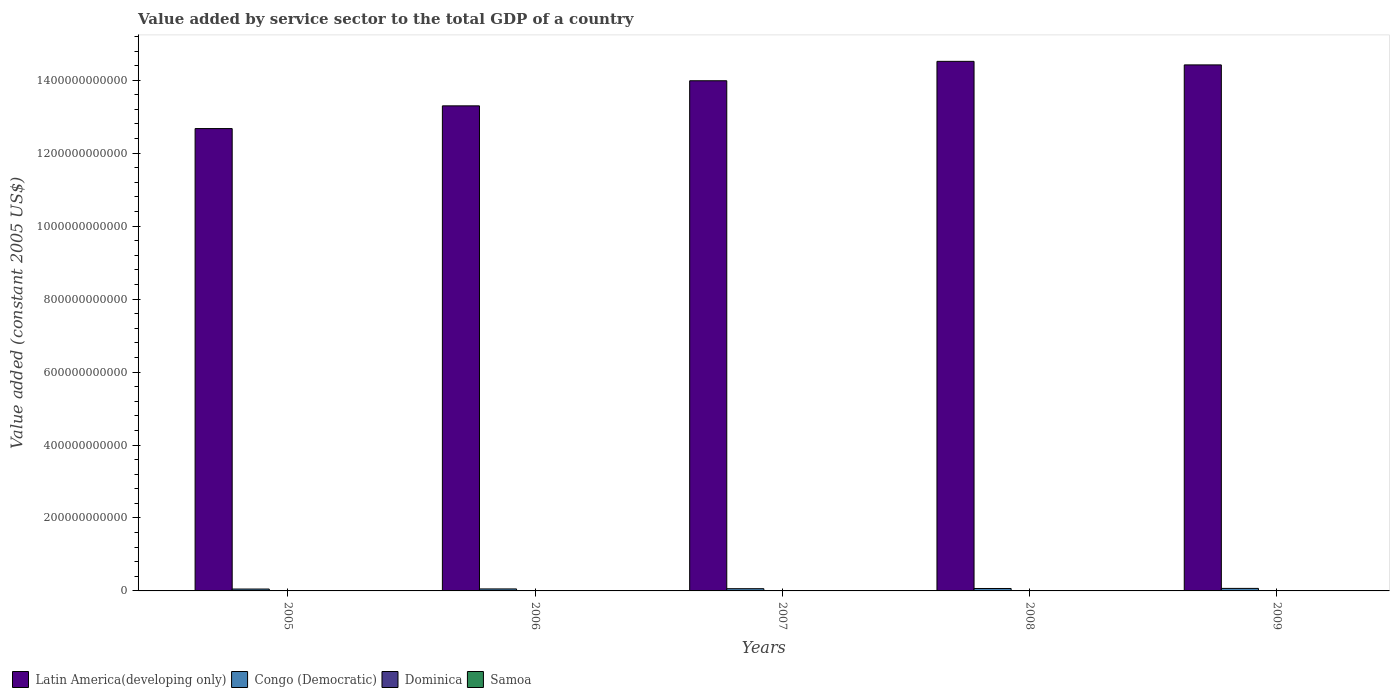How many groups of bars are there?
Make the answer very short. 5. Are the number of bars per tick equal to the number of legend labels?
Offer a terse response. Yes. Are the number of bars on each tick of the X-axis equal?
Provide a short and direct response. Yes. How many bars are there on the 5th tick from the right?
Offer a terse response. 4. What is the value added by service sector in Dominica in 2009?
Offer a very short reply. 2.55e+08. Across all years, what is the maximum value added by service sector in Dominica?
Your answer should be compact. 2.55e+08. Across all years, what is the minimum value added by service sector in Samoa?
Offer a terse response. 2.63e+08. What is the total value added by service sector in Congo (Democratic) in the graph?
Keep it short and to the point. 3.03e+1. What is the difference between the value added by service sector in Samoa in 2008 and that in 2009?
Ensure brevity in your answer.  -4.39e+06. What is the difference between the value added by service sector in Samoa in 2007 and the value added by service sector in Latin America(developing only) in 2006?
Your answer should be compact. -1.33e+12. What is the average value added by service sector in Dominica per year?
Your response must be concise. 2.40e+08. In the year 2008, what is the difference between the value added by service sector in Dominica and value added by service sector in Latin America(developing only)?
Provide a short and direct response. -1.45e+12. In how many years, is the value added by service sector in Dominica greater than 360000000000 US$?
Offer a very short reply. 0. What is the ratio of the value added by service sector in Latin America(developing only) in 2006 to that in 2009?
Make the answer very short. 0.92. Is the difference between the value added by service sector in Dominica in 2005 and 2008 greater than the difference between the value added by service sector in Latin America(developing only) in 2005 and 2008?
Offer a very short reply. Yes. What is the difference between the highest and the second highest value added by service sector in Dominica?
Your answer should be very brief. 1.10e+06. What is the difference between the highest and the lowest value added by service sector in Samoa?
Give a very brief answer. 3.37e+07. In how many years, is the value added by service sector in Congo (Democratic) greater than the average value added by service sector in Congo (Democratic) taken over all years?
Offer a very short reply. 3. What does the 2nd bar from the left in 2005 represents?
Your answer should be very brief. Congo (Democratic). What does the 3rd bar from the right in 2008 represents?
Provide a short and direct response. Congo (Democratic). Is it the case that in every year, the sum of the value added by service sector in Samoa and value added by service sector in Dominica is greater than the value added by service sector in Congo (Democratic)?
Your answer should be compact. No. How many bars are there?
Offer a terse response. 20. What is the difference between two consecutive major ticks on the Y-axis?
Ensure brevity in your answer.  2.00e+11. Does the graph contain any zero values?
Offer a very short reply. No. Does the graph contain grids?
Provide a succinct answer. No. Where does the legend appear in the graph?
Your answer should be very brief. Bottom left. How are the legend labels stacked?
Keep it short and to the point. Horizontal. What is the title of the graph?
Keep it short and to the point. Value added by service sector to the total GDP of a country. What is the label or title of the X-axis?
Ensure brevity in your answer.  Years. What is the label or title of the Y-axis?
Make the answer very short. Value added (constant 2005 US$). What is the Value added (constant 2005 US$) of Latin America(developing only) in 2005?
Your response must be concise. 1.27e+12. What is the Value added (constant 2005 US$) in Congo (Democratic) in 2005?
Offer a very short reply. 5.15e+09. What is the Value added (constant 2005 US$) in Dominica in 2005?
Your answer should be very brief. 2.25e+08. What is the Value added (constant 2005 US$) in Samoa in 2005?
Offer a very short reply. 2.63e+08. What is the Value added (constant 2005 US$) of Latin America(developing only) in 2006?
Keep it short and to the point. 1.33e+12. What is the Value added (constant 2005 US$) in Congo (Democratic) in 2006?
Give a very brief answer. 5.47e+09. What is the Value added (constant 2005 US$) of Dominica in 2006?
Keep it short and to the point. 2.27e+08. What is the Value added (constant 2005 US$) in Samoa in 2006?
Keep it short and to the point. 2.75e+08. What is the Value added (constant 2005 US$) in Latin America(developing only) in 2007?
Make the answer very short. 1.40e+12. What is the Value added (constant 2005 US$) in Congo (Democratic) in 2007?
Offer a terse response. 6.09e+09. What is the Value added (constant 2005 US$) of Dominica in 2007?
Provide a succinct answer. 2.40e+08. What is the Value added (constant 2005 US$) in Samoa in 2007?
Give a very brief answer. 2.84e+08. What is the Value added (constant 2005 US$) in Latin America(developing only) in 2008?
Offer a very short reply. 1.45e+12. What is the Value added (constant 2005 US$) in Congo (Democratic) in 2008?
Ensure brevity in your answer.  6.65e+09. What is the Value added (constant 2005 US$) of Dominica in 2008?
Give a very brief answer. 2.54e+08. What is the Value added (constant 2005 US$) in Samoa in 2008?
Provide a short and direct response. 2.93e+08. What is the Value added (constant 2005 US$) in Latin America(developing only) in 2009?
Provide a succinct answer. 1.44e+12. What is the Value added (constant 2005 US$) in Congo (Democratic) in 2009?
Your response must be concise. 6.90e+09. What is the Value added (constant 2005 US$) in Dominica in 2009?
Your answer should be very brief. 2.55e+08. What is the Value added (constant 2005 US$) in Samoa in 2009?
Your response must be concise. 2.97e+08. Across all years, what is the maximum Value added (constant 2005 US$) of Latin America(developing only)?
Provide a succinct answer. 1.45e+12. Across all years, what is the maximum Value added (constant 2005 US$) of Congo (Democratic)?
Make the answer very short. 6.90e+09. Across all years, what is the maximum Value added (constant 2005 US$) of Dominica?
Keep it short and to the point. 2.55e+08. Across all years, what is the maximum Value added (constant 2005 US$) of Samoa?
Make the answer very short. 2.97e+08. Across all years, what is the minimum Value added (constant 2005 US$) of Latin America(developing only)?
Your response must be concise. 1.27e+12. Across all years, what is the minimum Value added (constant 2005 US$) in Congo (Democratic)?
Your response must be concise. 5.15e+09. Across all years, what is the minimum Value added (constant 2005 US$) of Dominica?
Provide a succinct answer. 2.25e+08. Across all years, what is the minimum Value added (constant 2005 US$) in Samoa?
Keep it short and to the point. 2.63e+08. What is the total Value added (constant 2005 US$) in Latin America(developing only) in the graph?
Offer a very short reply. 6.89e+12. What is the total Value added (constant 2005 US$) in Congo (Democratic) in the graph?
Offer a very short reply. 3.03e+1. What is the total Value added (constant 2005 US$) of Dominica in the graph?
Your response must be concise. 1.20e+09. What is the total Value added (constant 2005 US$) in Samoa in the graph?
Keep it short and to the point. 1.41e+09. What is the difference between the Value added (constant 2005 US$) in Latin America(developing only) in 2005 and that in 2006?
Ensure brevity in your answer.  -6.23e+1. What is the difference between the Value added (constant 2005 US$) in Congo (Democratic) in 2005 and that in 2006?
Offer a terse response. -3.24e+08. What is the difference between the Value added (constant 2005 US$) of Dominica in 2005 and that in 2006?
Offer a terse response. -2.37e+06. What is the difference between the Value added (constant 2005 US$) of Samoa in 2005 and that in 2006?
Offer a terse response. -1.19e+07. What is the difference between the Value added (constant 2005 US$) in Latin America(developing only) in 2005 and that in 2007?
Give a very brief answer. -1.31e+11. What is the difference between the Value added (constant 2005 US$) of Congo (Democratic) in 2005 and that in 2007?
Your answer should be compact. -9.38e+08. What is the difference between the Value added (constant 2005 US$) in Dominica in 2005 and that in 2007?
Provide a short and direct response. -1.53e+07. What is the difference between the Value added (constant 2005 US$) in Samoa in 2005 and that in 2007?
Offer a terse response. -2.05e+07. What is the difference between the Value added (constant 2005 US$) in Latin America(developing only) in 2005 and that in 2008?
Keep it short and to the point. -1.84e+11. What is the difference between the Value added (constant 2005 US$) in Congo (Democratic) in 2005 and that in 2008?
Make the answer very short. -1.50e+09. What is the difference between the Value added (constant 2005 US$) in Dominica in 2005 and that in 2008?
Provide a succinct answer. -2.89e+07. What is the difference between the Value added (constant 2005 US$) of Samoa in 2005 and that in 2008?
Make the answer very short. -2.93e+07. What is the difference between the Value added (constant 2005 US$) in Latin America(developing only) in 2005 and that in 2009?
Your response must be concise. -1.75e+11. What is the difference between the Value added (constant 2005 US$) of Congo (Democratic) in 2005 and that in 2009?
Provide a short and direct response. -1.75e+09. What is the difference between the Value added (constant 2005 US$) of Dominica in 2005 and that in 2009?
Keep it short and to the point. -3.00e+07. What is the difference between the Value added (constant 2005 US$) of Samoa in 2005 and that in 2009?
Offer a very short reply. -3.37e+07. What is the difference between the Value added (constant 2005 US$) of Latin America(developing only) in 2006 and that in 2007?
Provide a succinct answer. -6.88e+1. What is the difference between the Value added (constant 2005 US$) in Congo (Democratic) in 2006 and that in 2007?
Provide a succinct answer. -6.14e+08. What is the difference between the Value added (constant 2005 US$) of Dominica in 2006 and that in 2007?
Your answer should be compact. -1.29e+07. What is the difference between the Value added (constant 2005 US$) of Samoa in 2006 and that in 2007?
Provide a succinct answer. -8.64e+06. What is the difference between the Value added (constant 2005 US$) in Latin America(developing only) in 2006 and that in 2008?
Keep it short and to the point. -1.22e+11. What is the difference between the Value added (constant 2005 US$) in Congo (Democratic) in 2006 and that in 2008?
Make the answer very short. -1.18e+09. What is the difference between the Value added (constant 2005 US$) in Dominica in 2006 and that in 2008?
Ensure brevity in your answer.  -2.65e+07. What is the difference between the Value added (constant 2005 US$) of Samoa in 2006 and that in 2008?
Your answer should be very brief. -1.74e+07. What is the difference between the Value added (constant 2005 US$) in Latin America(developing only) in 2006 and that in 2009?
Ensure brevity in your answer.  -1.12e+11. What is the difference between the Value added (constant 2005 US$) in Congo (Democratic) in 2006 and that in 2009?
Your response must be concise. -1.43e+09. What is the difference between the Value added (constant 2005 US$) in Dominica in 2006 and that in 2009?
Your response must be concise. -2.76e+07. What is the difference between the Value added (constant 2005 US$) in Samoa in 2006 and that in 2009?
Make the answer very short. -2.18e+07. What is the difference between the Value added (constant 2005 US$) of Latin America(developing only) in 2007 and that in 2008?
Ensure brevity in your answer.  -5.32e+1. What is the difference between the Value added (constant 2005 US$) of Congo (Democratic) in 2007 and that in 2008?
Make the answer very short. -5.62e+08. What is the difference between the Value added (constant 2005 US$) of Dominica in 2007 and that in 2008?
Provide a short and direct response. -1.36e+07. What is the difference between the Value added (constant 2005 US$) in Samoa in 2007 and that in 2008?
Your answer should be compact. -8.78e+06. What is the difference between the Value added (constant 2005 US$) in Latin America(developing only) in 2007 and that in 2009?
Give a very brief answer. -4.35e+1. What is the difference between the Value added (constant 2005 US$) in Congo (Democratic) in 2007 and that in 2009?
Provide a short and direct response. -8.13e+08. What is the difference between the Value added (constant 2005 US$) in Dominica in 2007 and that in 2009?
Your answer should be compact. -1.47e+07. What is the difference between the Value added (constant 2005 US$) in Samoa in 2007 and that in 2009?
Make the answer very short. -1.32e+07. What is the difference between the Value added (constant 2005 US$) in Latin America(developing only) in 2008 and that in 2009?
Your response must be concise. 9.73e+09. What is the difference between the Value added (constant 2005 US$) of Congo (Democratic) in 2008 and that in 2009?
Provide a short and direct response. -2.52e+08. What is the difference between the Value added (constant 2005 US$) of Dominica in 2008 and that in 2009?
Offer a terse response. -1.10e+06. What is the difference between the Value added (constant 2005 US$) in Samoa in 2008 and that in 2009?
Give a very brief answer. -4.39e+06. What is the difference between the Value added (constant 2005 US$) in Latin America(developing only) in 2005 and the Value added (constant 2005 US$) in Congo (Democratic) in 2006?
Provide a succinct answer. 1.26e+12. What is the difference between the Value added (constant 2005 US$) in Latin America(developing only) in 2005 and the Value added (constant 2005 US$) in Dominica in 2006?
Provide a succinct answer. 1.27e+12. What is the difference between the Value added (constant 2005 US$) in Latin America(developing only) in 2005 and the Value added (constant 2005 US$) in Samoa in 2006?
Your response must be concise. 1.27e+12. What is the difference between the Value added (constant 2005 US$) of Congo (Democratic) in 2005 and the Value added (constant 2005 US$) of Dominica in 2006?
Your answer should be compact. 4.92e+09. What is the difference between the Value added (constant 2005 US$) in Congo (Democratic) in 2005 and the Value added (constant 2005 US$) in Samoa in 2006?
Ensure brevity in your answer.  4.87e+09. What is the difference between the Value added (constant 2005 US$) of Dominica in 2005 and the Value added (constant 2005 US$) of Samoa in 2006?
Keep it short and to the point. -5.05e+07. What is the difference between the Value added (constant 2005 US$) of Latin America(developing only) in 2005 and the Value added (constant 2005 US$) of Congo (Democratic) in 2007?
Offer a very short reply. 1.26e+12. What is the difference between the Value added (constant 2005 US$) of Latin America(developing only) in 2005 and the Value added (constant 2005 US$) of Dominica in 2007?
Provide a succinct answer. 1.27e+12. What is the difference between the Value added (constant 2005 US$) of Latin America(developing only) in 2005 and the Value added (constant 2005 US$) of Samoa in 2007?
Your answer should be compact. 1.27e+12. What is the difference between the Value added (constant 2005 US$) in Congo (Democratic) in 2005 and the Value added (constant 2005 US$) in Dominica in 2007?
Keep it short and to the point. 4.91e+09. What is the difference between the Value added (constant 2005 US$) in Congo (Democratic) in 2005 and the Value added (constant 2005 US$) in Samoa in 2007?
Your answer should be compact. 4.87e+09. What is the difference between the Value added (constant 2005 US$) in Dominica in 2005 and the Value added (constant 2005 US$) in Samoa in 2007?
Offer a terse response. -5.91e+07. What is the difference between the Value added (constant 2005 US$) of Latin America(developing only) in 2005 and the Value added (constant 2005 US$) of Congo (Democratic) in 2008?
Provide a succinct answer. 1.26e+12. What is the difference between the Value added (constant 2005 US$) of Latin America(developing only) in 2005 and the Value added (constant 2005 US$) of Dominica in 2008?
Provide a succinct answer. 1.27e+12. What is the difference between the Value added (constant 2005 US$) of Latin America(developing only) in 2005 and the Value added (constant 2005 US$) of Samoa in 2008?
Your answer should be compact. 1.27e+12. What is the difference between the Value added (constant 2005 US$) of Congo (Democratic) in 2005 and the Value added (constant 2005 US$) of Dominica in 2008?
Ensure brevity in your answer.  4.90e+09. What is the difference between the Value added (constant 2005 US$) of Congo (Democratic) in 2005 and the Value added (constant 2005 US$) of Samoa in 2008?
Ensure brevity in your answer.  4.86e+09. What is the difference between the Value added (constant 2005 US$) of Dominica in 2005 and the Value added (constant 2005 US$) of Samoa in 2008?
Provide a succinct answer. -6.79e+07. What is the difference between the Value added (constant 2005 US$) in Latin America(developing only) in 2005 and the Value added (constant 2005 US$) in Congo (Democratic) in 2009?
Provide a succinct answer. 1.26e+12. What is the difference between the Value added (constant 2005 US$) in Latin America(developing only) in 2005 and the Value added (constant 2005 US$) in Dominica in 2009?
Keep it short and to the point. 1.27e+12. What is the difference between the Value added (constant 2005 US$) in Latin America(developing only) in 2005 and the Value added (constant 2005 US$) in Samoa in 2009?
Make the answer very short. 1.27e+12. What is the difference between the Value added (constant 2005 US$) in Congo (Democratic) in 2005 and the Value added (constant 2005 US$) in Dominica in 2009?
Your answer should be compact. 4.90e+09. What is the difference between the Value added (constant 2005 US$) of Congo (Democratic) in 2005 and the Value added (constant 2005 US$) of Samoa in 2009?
Your answer should be compact. 4.85e+09. What is the difference between the Value added (constant 2005 US$) in Dominica in 2005 and the Value added (constant 2005 US$) in Samoa in 2009?
Provide a short and direct response. -7.23e+07. What is the difference between the Value added (constant 2005 US$) in Latin America(developing only) in 2006 and the Value added (constant 2005 US$) in Congo (Democratic) in 2007?
Provide a short and direct response. 1.32e+12. What is the difference between the Value added (constant 2005 US$) in Latin America(developing only) in 2006 and the Value added (constant 2005 US$) in Dominica in 2007?
Offer a terse response. 1.33e+12. What is the difference between the Value added (constant 2005 US$) in Latin America(developing only) in 2006 and the Value added (constant 2005 US$) in Samoa in 2007?
Make the answer very short. 1.33e+12. What is the difference between the Value added (constant 2005 US$) of Congo (Democratic) in 2006 and the Value added (constant 2005 US$) of Dominica in 2007?
Provide a succinct answer. 5.23e+09. What is the difference between the Value added (constant 2005 US$) of Congo (Democratic) in 2006 and the Value added (constant 2005 US$) of Samoa in 2007?
Offer a terse response. 5.19e+09. What is the difference between the Value added (constant 2005 US$) in Dominica in 2006 and the Value added (constant 2005 US$) in Samoa in 2007?
Ensure brevity in your answer.  -5.67e+07. What is the difference between the Value added (constant 2005 US$) in Latin America(developing only) in 2006 and the Value added (constant 2005 US$) in Congo (Democratic) in 2008?
Your response must be concise. 1.32e+12. What is the difference between the Value added (constant 2005 US$) of Latin America(developing only) in 2006 and the Value added (constant 2005 US$) of Dominica in 2008?
Your answer should be compact. 1.33e+12. What is the difference between the Value added (constant 2005 US$) of Latin America(developing only) in 2006 and the Value added (constant 2005 US$) of Samoa in 2008?
Ensure brevity in your answer.  1.33e+12. What is the difference between the Value added (constant 2005 US$) in Congo (Democratic) in 2006 and the Value added (constant 2005 US$) in Dominica in 2008?
Provide a succinct answer. 5.22e+09. What is the difference between the Value added (constant 2005 US$) in Congo (Democratic) in 2006 and the Value added (constant 2005 US$) in Samoa in 2008?
Give a very brief answer. 5.18e+09. What is the difference between the Value added (constant 2005 US$) of Dominica in 2006 and the Value added (constant 2005 US$) of Samoa in 2008?
Give a very brief answer. -6.55e+07. What is the difference between the Value added (constant 2005 US$) in Latin America(developing only) in 2006 and the Value added (constant 2005 US$) in Congo (Democratic) in 2009?
Provide a short and direct response. 1.32e+12. What is the difference between the Value added (constant 2005 US$) in Latin America(developing only) in 2006 and the Value added (constant 2005 US$) in Dominica in 2009?
Ensure brevity in your answer.  1.33e+12. What is the difference between the Value added (constant 2005 US$) in Latin America(developing only) in 2006 and the Value added (constant 2005 US$) in Samoa in 2009?
Your answer should be very brief. 1.33e+12. What is the difference between the Value added (constant 2005 US$) of Congo (Democratic) in 2006 and the Value added (constant 2005 US$) of Dominica in 2009?
Ensure brevity in your answer.  5.22e+09. What is the difference between the Value added (constant 2005 US$) in Congo (Democratic) in 2006 and the Value added (constant 2005 US$) in Samoa in 2009?
Make the answer very short. 5.18e+09. What is the difference between the Value added (constant 2005 US$) in Dominica in 2006 and the Value added (constant 2005 US$) in Samoa in 2009?
Your response must be concise. -6.99e+07. What is the difference between the Value added (constant 2005 US$) in Latin America(developing only) in 2007 and the Value added (constant 2005 US$) in Congo (Democratic) in 2008?
Offer a terse response. 1.39e+12. What is the difference between the Value added (constant 2005 US$) of Latin America(developing only) in 2007 and the Value added (constant 2005 US$) of Dominica in 2008?
Your response must be concise. 1.40e+12. What is the difference between the Value added (constant 2005 US$) of Latin America(developing only) in 2007 and the Value added (constant 2005 US$) of Samoa in 2008?
Your response must be concise. 1.40e+12. What is the difference between the Value added (constant 2005 US$) in Congo (Democratic) in 2007 and the Value added (constant 2005 US$) in Dominica in 2008?
Offer a terse response. 5.83e+09. What is the difference between the Value added (constant 2005 US$) of Congo (Democratic) in 2007 and the Value added (constant 2005 US$) of Samoa in 2008?
Offer a terse response. 5.80e+09. What is the difference between the Value added (constant 2005 US$) in Dominica in 2007 and the Value added (constant 2005 US$) in Samoa in 2008?
Your response must be concise. -5.26e+07. What is the difference between the Value added (constant 2005 US$) of Latin America(developing only) in 2007 and the Value added (constant 2005 US$) of Congo (Democratic) in 2009?
Your response must be concise. 1.39e+12. What is the difference between the Value added (constant 2005 US$) in Latin America(developing only) in 2007 and the Value added (constant 2005 US$) in Dominica in 2009?
Your response must be concise. 1.40e+12. What is the difference between the Value added (constant 2005 US$) in Latin America(developing only) in 2007 and the Value added (constant 2005 US$) in Samoa in 2009?
Offer a very short reply. 1.40e+12. What is the difference between the Value added (constant 2005 US$) in Congo (Democratic) in 2007 and the Value added (constant 2005 US$) in Dominica in 2009?
Your answer should be compact. 5.83e+09. What is the difference between the Value added (constant 2005 US$) in Congo (Democratic) in 2007 and the Value added (constant 2005 US$) in Samoa in 2009?
Your response must be concise. 5.79e+09. What is the difference between the Value added (constant 2005 US$) of Dominica in 2007 and the Value added (constant 2005 US$) of Samoa in 2009?
Keep it short and to the point. -5.70e+07. What is the difference between the Value added (constant 2005 US$) of Latin America(developing only) in 2008 and the Value added (constant 2005 US$) of Congo (Democratic) in 2009?
Offer a terse response. 1.44e+12. What is the difference between the Value added (constant 2005 US$) in Latin America(developing only) in 2008 and the Value added (constant 2005 US$) in Dominica in 2009?
Keep it short and to the point. 1.45e+12. What is the difference between the Value added (constant 2005 US$) of Latin America(developing only) in 2008 and the Value added (constant 2005 US$) of Samoa in 2009?
Offer a very short reply. 1.45e+12. What is the difference between the Value added (constant 2005 US$) of Congo (Democratic) in 2008 and the Value added (constant 2005 US$) of Dominica in 2009?
Your answer should be compact. 6.40e+09. What is the difference between the Value added (constant 2005 US$) of Congo (Democratic) in 2008 and the Value added (constant 2005 US$) of Samoa in 2009?
Make the answer very short. 6.35e+09. What is the difference between the Value added (constant 2005 US$) of Dominica in 2008 and the Value added (constant 2005 US$) of Samoa in 2009?
Offer a terse response. -4.34e+07. What is the average Value added (constant 2005 US$) of Latin America(developing only) per year?
Provide a succinct answer. 1.38e+12. What is the average Value added (constant 2005 US$) of Congo (Democratic) per year?
Ensure brevity in your answer.  6.05e+09. What is the average Value added (constant 2005 US$) in Dominica per year?
Your answer should be very brief. 2.40e+08. What is the average Value added (constant 2005 US$) of Samoa per year?
Your answer should be very brief. 2.82e+08. In the year 2005, what is the difference between the Value added (constant 2005 US$) in Latin America(developing only) and Value added (constant 2005 US$) in Congo (Democratic)?
Keep it short and to the point. 1.26e+12. In the year 2005, what is the difference between the Value added (constant 2005 US$) in Latin America(developing only) and Value added (constant 2005 US$) in Dominica?
Your answer should be compact. 1.27e+12. In the year 2005, what is the difference between the Value added (constant 2005 US$) in Latin America(developing only) and Value added (constant 2005 US$) in Samoa?
Offer a terse response. 1.27e+12. In the year 2005, what is the difference between the Value added (constant 2005 US$) in Congo (Democratic) and Value added (constant 2005 US$) in Dominica?
Give a very brief answer. 4.93e+09. In the year 2005, what is the difference between the Value added (constant 2005 US$) of Congo (Democratic) and Value added (constant 2005 US$) of Samoa?
Provide a short and direct response. 4.89e+09. In the year 2005, what is the difference between the Value added (constant 2005 US$) of Dominica and Value added (constant 2005 US$) of Samoa?
Your response must be concise. -3.86e+07. In the year 2006, what is the difference between the Value added (constant 2005 US$) in Latin America(developing only) and Value added (constant 2005 US$) in Congo (Democratic)?
Provide a succinct answer. 1.32e+12. In the year 2006, what is the difference between the Value added (constant 2005 US$) of Latin America(developing only) and Value added (constant 2005 US$) of Dominica?
Your answer should be very brief. 1.33e+12. In the year 2006, what is the difference between the Value added (constant 2005 US$) in Latin America(developing only) and Value added (constant 2005 US$) in Samoa?
Your answer should be very brief. 1.33e+12. In the year 2006, what is the difference between the Value added (constant 2005 US$) in Congo (Democratic) and Value added (constant 2005 US$) in Dominica?
Your response must be concise. 5.25e+09. In the year 2006, what is the difference between the Value added (constant 2005 US$) in Congo (Democratic) and Value added (constant 2005 US$) in Samoa?
Give a very brief answer. 5.20e+09. In the year 2006, what is the difference between the Value added (constant 2005 US$) in Dominica and Value added (constant 2005 US$) in Samoa?
Offer a very short reply. -4.81e+07. In the year 2007, what is the difference between the Value added (constant 2005 US$) of Latin America(developing only) and Value added (constant 2005 US$) of Congo (Democratic)?
Provide a short and direct response. 1.39e+12. In the year 2007, what is the difference between the Value added (constant 2005 US$) of Latin America(developing only) and Value added (constant 2005 US$) of Dominica?
Keep it short and to the point. 1.40e+12. In the year 2007, what is the difference between the Value added (constant 2005 US$) of Latin America(developing only) and Value added (constant 2005 US$) of Samoa?
Provide a short and direct response. 1.40e+12. In the year 2007, what is the difference between the Value added (constant 2005 US$) of Congo (Democratic) and Value added (constant 2005 US$) of Dominica?
Provide a short and direct response. 5.85e+09. In the year 2007, what is the difference between the Value added (constant 2005 US$) of Congo (Democratic) and Value added (constant 2005 US$) of Samoa?
Offer a very short reply. 5.80e+09. In the year 2007, what is the difference between the Value added (constant 2005 US$) of Dominica and Value added (constant 2005 US$) of Samoa?
Provide a succinct answer. -4.38e+07. In the year 2008, what is the difference between the Value added (constant 2005 US$) of Latin America(developing only) and Value added (constant 2005 US$) of Congo (Democratic)?
Give a very brief answer. 1.45e+12. In the year 2008, what is the difference between the Value added (constant 2005 US$) in Latin America(developing only) and Value added (constant 2005 US$) in Dominica?
Keep it short and to the point. 1.45e+12. In the year 2008, what is the difference between the Value added (constant 2005 US$) of Latin America(developing only) and Value added (constant 2005 US$) of Samoa?
Offer a terse response. 1.45e+12. In the year 2008, what is the difference between the Value added (constant 2005 US$) of Congo (Democratic) and Value added (constant 2005 US$) of Dominica?
Your response must be concise. 6.40e+09. In the year 2008, what is the difference between the Value added (constant 2005 US$) in Congo (Democratic) and Value added (constant 2005 US$) in Samoa?
Your answer should be compact. 6.36e+09. In the year 2008, what is the difference between the Value added (constant 2005 US$) of Dominica and Value added (constant 2005 US$) of Samoa?
Your answer should be compact. -3.90e+07. In the year 2009, what is the difference between the Value added (constant 2005 US$) in Latin America(developing only) and Value added (constant 2005 US$) in Congo (Democratic)?
Keep it short and to the point. 1.44e+12. In the year 2009, what is the difference between the Value added (constant 2005 US$) in Latin America(developing only) and Value added (constant 2005 US$) in Dominica?
Your answer should be compact. 1.44e+12. In the year 2009, what is the difference between the Value added (constant 2005 US$) in Latin America(developing only) and Value added (constant 2005 US$) in Samoa?
Give a very brief answer. 1.44e+12. In the year 2009, what is the difference between the Value added (constant 2005 US$) of Congo (Democratic) and Value added (constant 2005 US$) of Dominica?
Your answer should be very brief. 6.65e+09. In the year 2009, what is the difference between the Value added (constant 2005 US$) of Congo (Democratic) and Value added (constant 2005 US$) of Samoa?
Your answer should be very brief. 6.60e+09. In the year 2009, what is the difference between the Value added (constant 2005 US$) in Dominica and Value added (constant 2005 US$) in Samoa?
Provide a short and direct response. -4.23e+07. What is the ratio of the Value added (constant 2005 US$) in Latin America(developing only) in 2005 to that in 2006?
Make the answer very short. 0.95. What is the ratio of the Value added (constant 2005 US$) of Congo (Democratic) in 2005 to that in 2006?
Your response must be concise. 0.94. What is the ratio of the Value added (constant 2005 US$) of Dominica in 2005 to that in 2006?
Provide a succinct answer. 0.99. What is the ratio of the Value added (constant 2005 US$) in Samoa in 2005 to that in 2006?
Ensure brevity in your answer.  0.96. What is the ratio of the Value added (constant 2005 US$) in Latin America(developing only) in 2005 to that in 2007?
Ensure brevity in your answer.  0.91. What is the ratio of the Value added (constant 2005 US$) in Congo (Democratic) in 2005 to that in 2007?
Provide a succinct answer. 0.85. What is the ratio of the Value added (constant 2005 US$) of Dominica in 2005 to that in 2007?
Your response must be concise. 0.94. What is the ratio of the Value added (constant 2005 US$) of Samoa in 2005 to that in 2007?
Offer a terse response. 0.93. What is the ratio of the Value added (constant 2005 US$) in Latin America(developing only) in 2005 to that in 2008?
Provide a short and direct response. 0.87. What is the ratio of the Value added (constant 2005 US$) of Congo (Democratic) in 2005 to that in 2008?
Provide a succinct answer. 0.77. What is the ratio of the Value added (constant 2005 US$) of Dominica in 2005 to that in 2008?
Your answer should be very brief. 0.89. What is the ratio of the Value added (constant 2005 US$) in Samoa in 2005 to that in 2008?
Give a very brief answer. 0.9. What is the ratio of the Value added (constant 2005 US$) in Latin America(developing only) in 2005 to that in 2009?
Provide a short and direct response. 0.88. What is the ratio of the Value added (constant 2005 US$) of Congo (Democratic) in 2005 to that in 2009?
Ensure brevity in your answer.  0.75. What is the ratio of the Value added (constant 2005 US$) in Dominica in 2005 to that in 2009?
Keep it short and to the point. 0.88. What is the ratio of the Value added (constant 2005 US$) in Samoa in 2005 to that in 2009?
Provide a succinct answer. 0.89. What is the ratio of the Value added (constant 2005 US$) of Latin America(developing only) in 2006 to that in 2007?
Offer a terse response. 0.95. What is the ratio of the Value added (constant 2005 US$) of Congo (Democratic) in 2006 to that in 2007?
Keep it short and to the point. 0.9. What is the ratio of the Value added (constant 2005 US$) of Dominica in 2006 to that in 2007?
Keep it short and to the point. 0.95. What is the ratio of the Value added (constant 2005 US$) of Samoa in 2006 to that in 2007?
Your answer should be compact. 0.97. What is the ratio of the Value added (constant 2005 US$) in Latin America(developing only) in 2006 to that in 2008?
Keep it short and to the point. 0.92. What is the ratio of the Value added (constant 2005 US$) in Congo (Democratic) in 2006 to that in 2008?
Offer a very short reply. 0.82. What is the ratio of the Value added (constant 2005 US$) of Dominica in 2006 to that in 2008?
Provide a short and direct response. 0.9. What is the ratio of the Value added (constant 2005 US$) of Samoa in 2006 to that in 2008?
Provide a short and direct response. 0.94. What is the ratio of the Value added (constant 2005 US$) in Latin America(developing only) in 2006 to that in 2009?
Provide a short and direct response. 0.92. What is the ratio of the Value added (constant 2005 US$) of Congo (Democratic) in 2006 to that in 2009?
Your answer should be compact. 0.79. What is the ratio of the Value added (constant 2005 US$) in Dominica in 2006 to that in 2009?
Your answer should be compact. 0.89. What is the ratio of the Value added (constant 2005 US$) of Samoa in 2006 to that in 2009?
Your response must be concise. 0.93. What is the ratio of the Value added (constant 2005 US$) of Latin America(developing only) in 2007 to that in 2008?
Provide a succinct answer. 0.96. What is the ratio of the Value added (constant 2005 US$) in Congo (Democratic) in 2007 to that in 2008?
Make the answer very short. 0.92. What is the ratio of the Value added (constant 2005 US$) of Dominica in 2007 to that in 2008?
Your answer should be very brief. 0.95. What is the ratio of the Value added (constant 2005 US$) of Samoa in 2007 to that in 2008?
Your response must be concise. 0.97. What is the ratio of the Value added (constant 2005 US$) of Latin America(developing only) in 2007 to that in 2009?
Provide a succinct answer. 0.97. What is the ratio of the Value added (constant 2005 US$) in Congo (Democratic) in 2007 to that in 2009?
Offer a very short reply. 0.88. What is the ratio of the Value added (constant 2005 US$) of Dominica in 2007 to that in 2009?
Provide a succinct answer. 0.94. What is the ratio of the Value added (constant 2005 US$) in Samoa in 2007 to that in 2009?
Keep it short and to the point. 0.96. What is the ratio of the Value added (constant 2005 US$) of Congo (Democratic) in 2008 to that in 2009?
Ensure brevity in your answer.  0.96. What is the ratio of the Value added (constant 2005 US$) of Dominica in 2008 to that in 2009?
Keep it short and to the point. 1. What is the ratio of the Value added (constant 2005 US$) in Samoa in 2008 to that in 2009?
Ensure brevity in your answer.  0.99. What is the difference between the highest and the second highest Value added (constant 2005 US$) in Latin America(developing only)?
Your response must be concise. 9.73e+09. What is the difference between the highest and the second highest Value added (constant 2005 US$) in Congo (Democratic)?
Your answer should be compact. 2.52e+08. What is the difference between the highest and the second highest Value added (constant 2005 US$) in Dominica?
Give a very brief answer. 1.10e+06. What is the difference between the highest and the second highest Value added (constant 2005 US$) of Samoa?
Keep it short and to the point. 4.39e+06. What is the difference between the highest and the lowest Value added (constant 2005 US$) of Latin America(developing only)?
Your answer should be very brief. 1.84e+11. What is the difference between the highest and the lowest Value added (constant 2005 US$) of Congo (Democratic)?
Provide a short and direct response. 1.75e+09. What is the difference between the highest and the lowest Value added (constant 2005 US$) in Dominica?
Ensure brevity in your answer.  3.00e+07. What is the difference between the highest and the lowest Value added (constant 2005 US$) in Samoa?
Provide a succinct answer. 3.37e+07. 